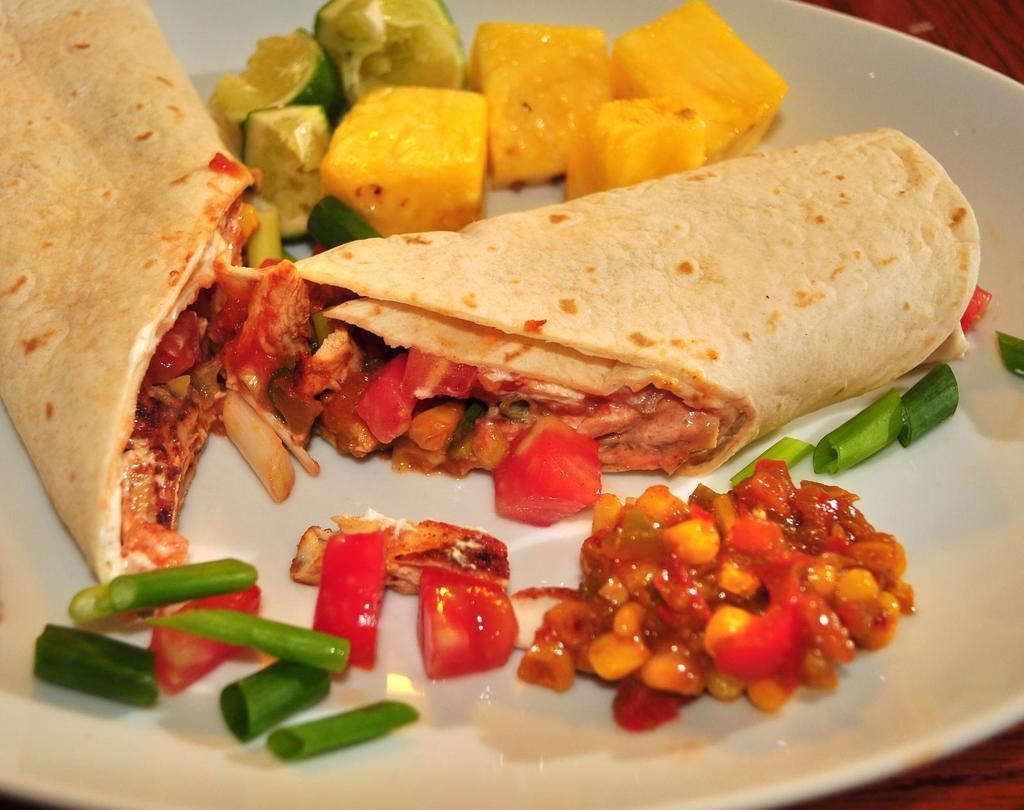What is present in the image? There are food items in the image. How are the food items arranged or displayed? The food items are in a white plate. What base is being used for the reading in the image? There is no reading or base present in the image; it only features food items in a white plate. 